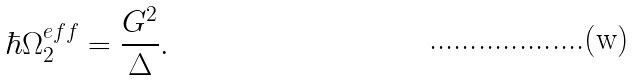<formula> <loc_0><loc_0><loc_500><loc_500>\hbar { \Omega } _ { 2 } ^ { e f f } = \frac { G ^ { 2 } } { \Delta } .</formula> 